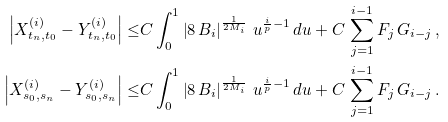Convert formula to latex. <formula><loc_0><loc_0><loc_500><loc_500>\left | X ^ { ( i ) } _ { t _ { n } , t _ { 0 } } - Y ^ { ( i ) } _ { t _ { n } , t _ { 0 } } \right | \leq & C \int _ { 0 } ^ { 1 } \left | 8 \, B _ { i } \right | ^ { \frac { 1 } { 2 M _ { i } } } \, u ^ { \frac { i } { p } - 1 } \, d u + C \, \sum _ { j = 1 } ^ { i - 1 } F _ { j } \, G _ { i - j } \, , \\ \left | X ^ { ( i ) } _ { s _ { 0 } , s _ { n } } - Y ^ { ( i ) } _ { s _ { 0 } , s _ { n } } \right | \leq & C \int _ { 0 } ^ { 1 } \left | 8 \, B _ { i } \right | ^ { \frac { 1 } { 2 M _ { i } } } \, u ^ { \frac { i } { p } - 1 } \, d u + C \, \sum _ { j = 1 } ^ { i - 1 } F _ { j } \, G _ { i - j } \, .</formula> 